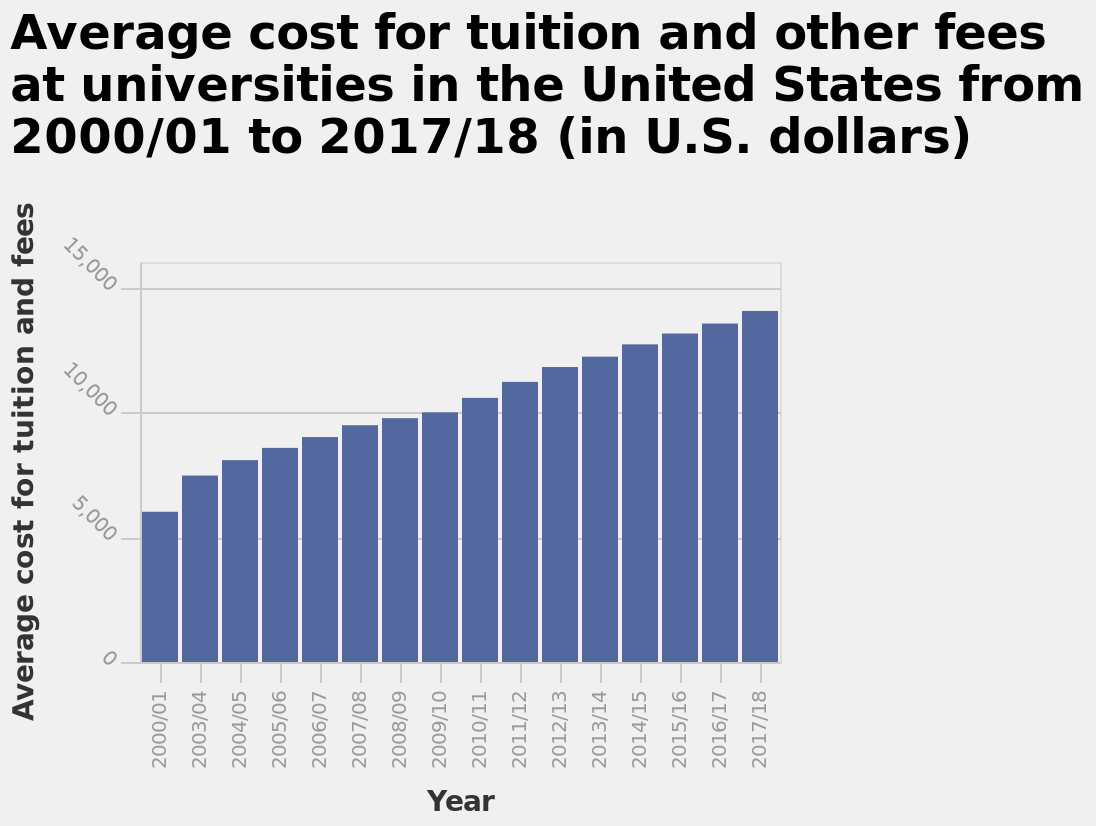<image>
What is the title or figure of the bar graph? The title or figure of the bar graph is "Average cost for tuition and other fees at universities in the United States from 2000/01 to 2017/18 (in U.S. dollars)". Is there a consistent trend in the cost of tuition fees?  Yes, there is a consistent increase in the cost of tuition fees. What does the x-axis represent on the bar graph? The x-axis represents the years from 2000/01 to 2017/18. 